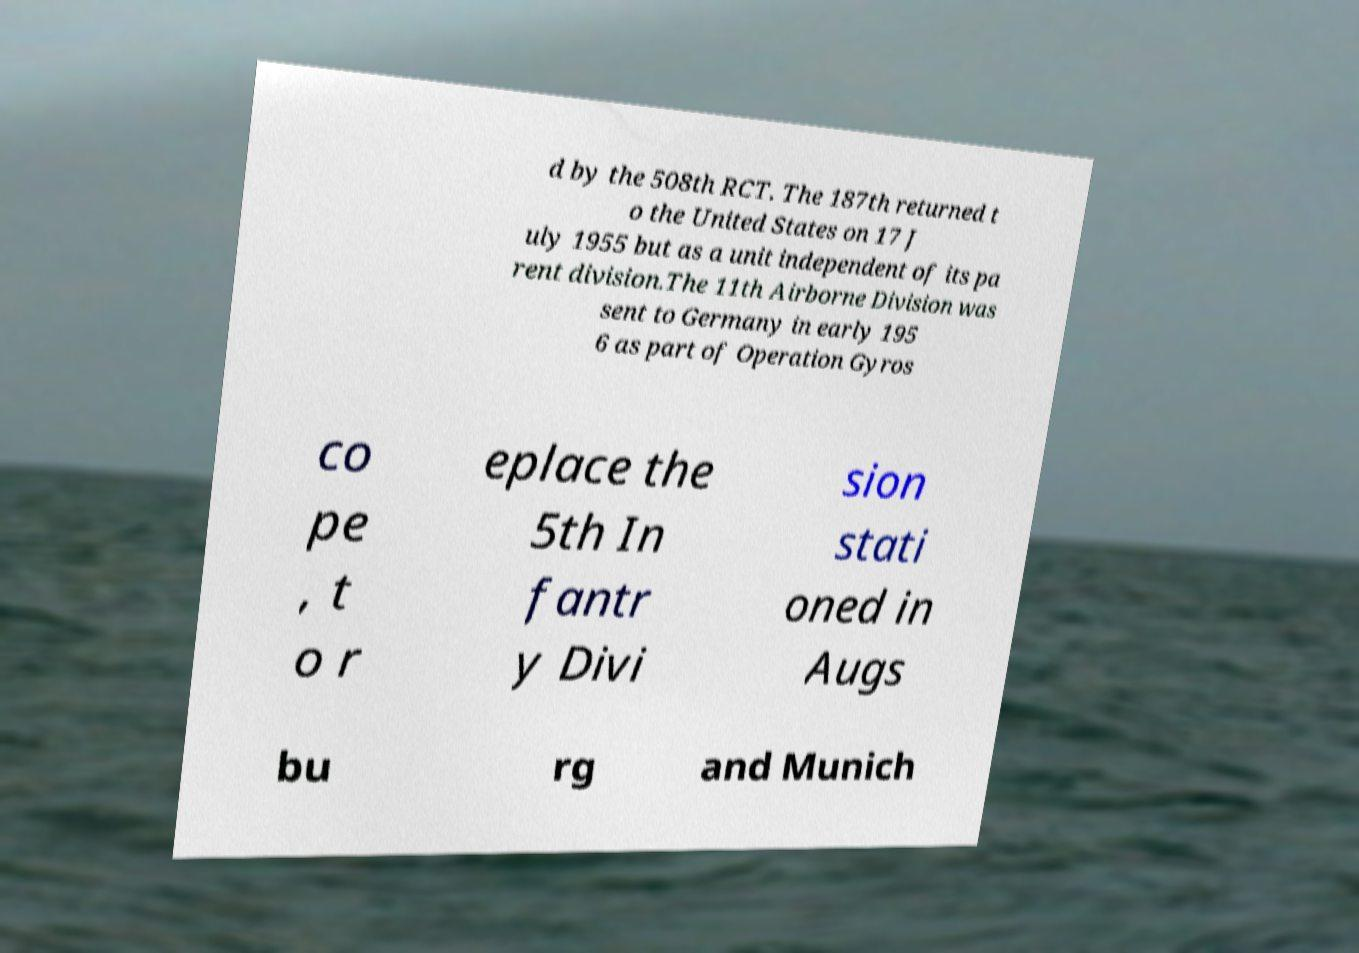There's text embedded in this image that I need extracted. Can you transcribe it verbatim? d by the 508th RCT. The 187th returned t o the United States on 17 J uly 1955 but as a unit independent of its pa rent division.The 11th Airborne Division was sent to Germany in early 195 6 as part of Operation Gyros co pe , t o r eplace the 5th In fantr y Divi sion stati oned in Augs bu rg and Munich 